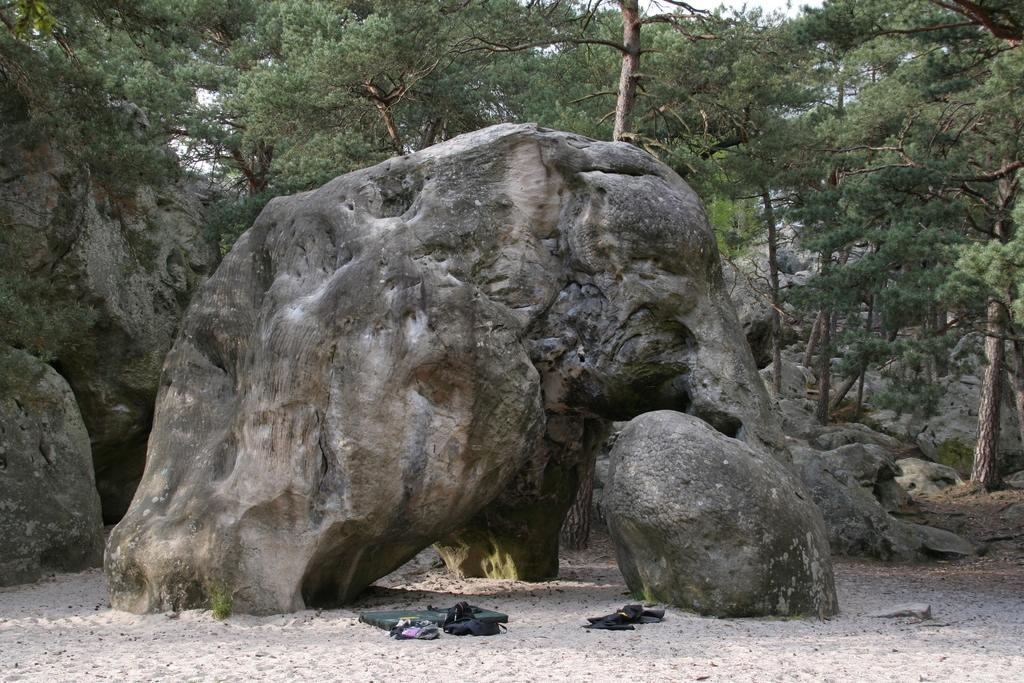What type of natural elements can be seen in the image? There are large stones and sand visible in the image. What can be seen in the background of the image? There are trees in the background of the image. Where is the shelf located in the image? There is no shelf present in the image. Can you see a rifle in the image? There is no rifle present in the image. 